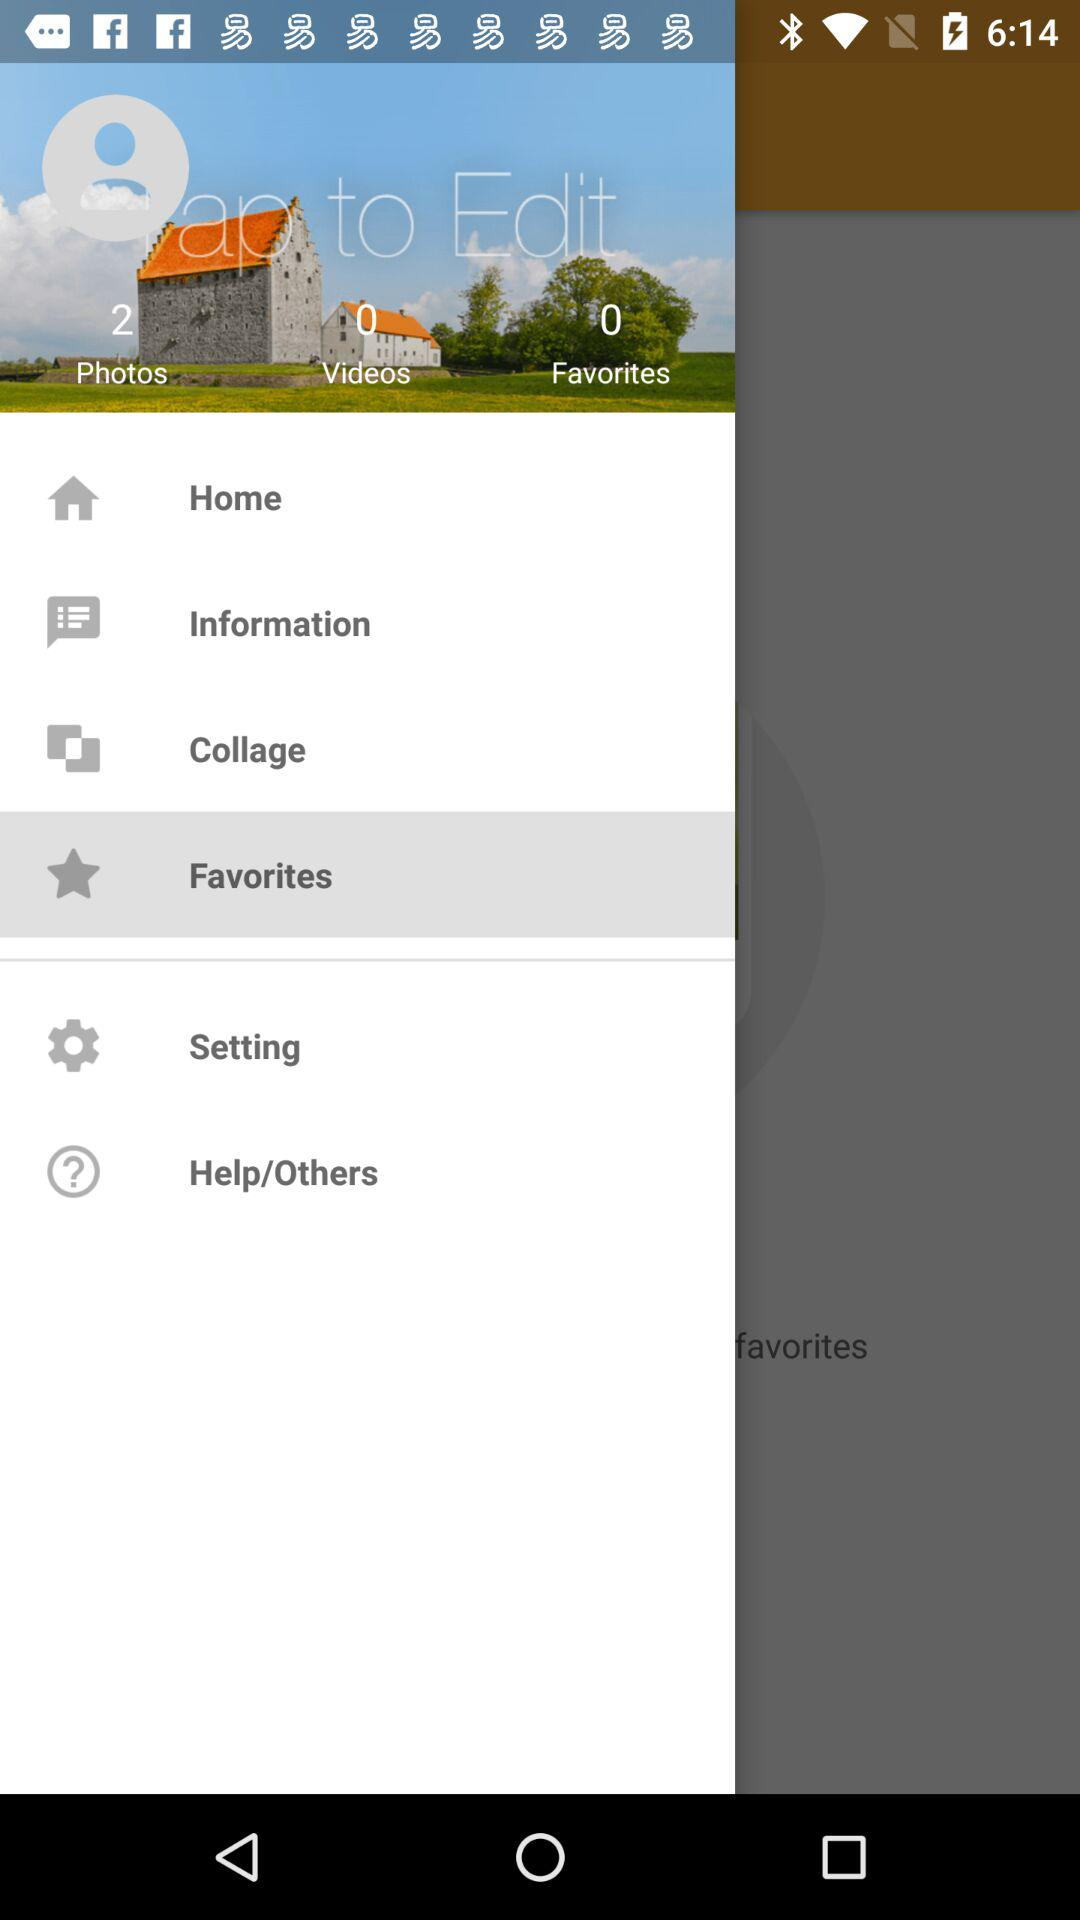Are there any favorites in the list? There are 0 favorites in the list. 